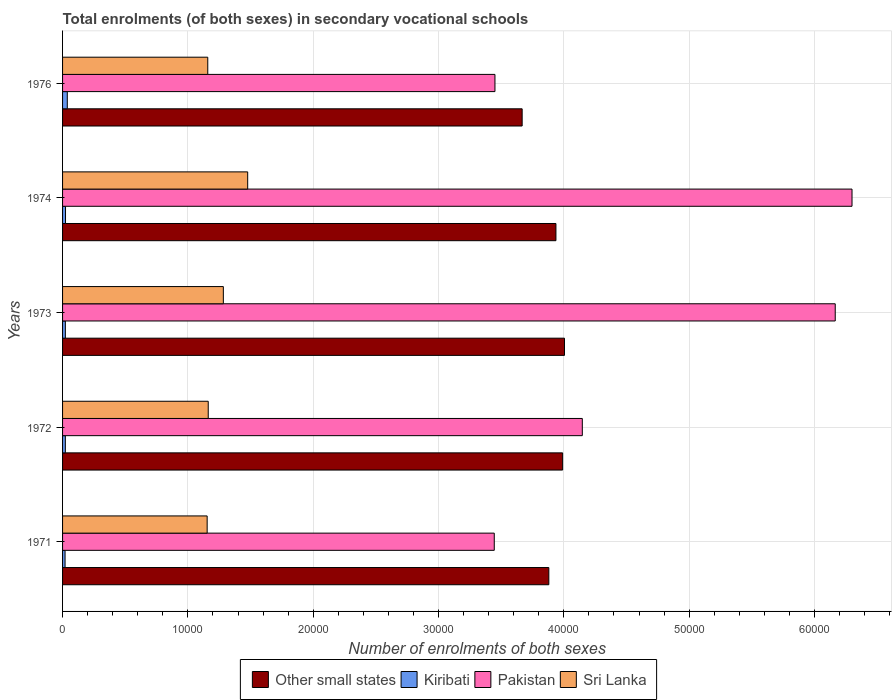How many different coloured bars are there?
Your answer should be very brief. 4. In how many cases, is the number of bars for a given year not equal to the number of legend labels?
Provide a succinct answer. 0. What is the number of enrolments in secondary schools in Pakistan in 1974?
Provide a short and direct response. 6.30e+04. Across all years, what is the maximum number of enrolments in secondary schools in Sri Lanka?
Provide a short and direct response. 1.48e+04. Across all years, what is the minimum number of enrolments in secondary schools in Kiribati?
Ensure brevity in your answer.  199. In which year was the number of enrolments in secondary schools in Pakistan maximum?
Your response must be concise. 1974. In which year was the number of enrolments in secondary schools in Sri Lanka minimum?
Offer a terse response. 1971. What is the total number of enrolments in secondary schools in Sri Lanka in the graph?
Provide a succinct answer. 6.24e+04. What is the difference between the number of enrolments in secondary schools in Pakistan in 1974 and that in 1976?
Provide a short and direct response. 2.85e+04. What is the difference between the number of enrolments in secondary schools in Other small states in 1973 and the number of enrolments in secondary schools in Sri Lanka in 1976?
Your answer should be compact. 2.85e+04. What is the average number of enrolments in secondary schools in Kiribati per year?
Make the answer very short. 251.4. In the year 1974, what is the difference between the number of enrolments in secondary schools in Other small states and number of enrolments in secondary schools in Sri Lanka?
Offer a terse response. 2.46e+04. What is the ratio of the number of enrolments in secondary schools in Kiribati in 1972 to that in 1976?
Offer a terse response. 0.59. Is the number of enrolments in secondary schools in Kiribati in 1971 less than that in 1973?
Make the answer very short. Yes. What is the difference between the highest and the second highest number of enrolments in secondary schools in Sri Lanka?
Provide a short and direct response. 1943. What is the difference between the highest and the lowest number of enrolments in secondary schools in Other small states?
Offer a terse response. 3377.85. In how many years, is the number of enrolments in secondary schools in Other small states greater than the average number of enrolments in secondary schools in Other small states taken over all years?
Your answer should be compact. 3. Is the sum of the number of enrolments in secondary schools in Kiribati in 1972 and 1974 greater than the maximum number of enrolments in secondary schools in Sri Lanka across all years?
Your answer should be compact. No. Is it the case that in every year, the sum of the number of enrolments in secondary schools in Pakistan and number of enrolments in secondary schools in Kiribati is greater than the sum of number of enrolments in secondary schools in Sri Lanka and number of enrolments in secondary schools in Other small states?
Your answer should be compact. Yes. What does the 1st bar from the top in 1971 represents?
Provide a short and direct response. Sri Lanka. What does the 3rd bar from the bottom in 1972 represents?
Give a very brief answer. Pakistan. Is it the case that in every year, the sum of the number of enrolments in secondary schools in Other small states and number of enrolments in secondary schools in Kiribati is greater than the number of enrolments in secondary schools in Sri Lanka?
Keep it short and to the point. Yes. Does the graph contain any zero values?
Offer a terse response. No. Does the graph contain grids?
Offer a very short reply. Yes. What is the title of the graph?
Ensure brevity in your answer.  Total enrolments (of both sexes) in secondary vocational schools. What is the label or title of the X-axis?
Provide a succinct answer. Number of enrolments of both sexes. What is the label or title of the Y-axis?
Provide a succinct answer. Years. What is the Number of enrolments of both sexes in Other small states in 1971?
Provide a succinct answer. 3.88e+04. What is the Number of enrolments of both sexes in Kiribati in 1971?
Provide a short and direct response. 199. What is the Number of enrolments of both sexes in Pakistan in 1971?
Ensure brevity in your answer.  3.44e+04. What is the Number of enrolments of both sexes of Sri Lanka in 1971?
Ensure brevity in your answer.  1.15e+04. What is the Number of enrolments of both sexes of Other small states in 1972?
Your response must be concise. 3.99e+04. What is the Number of enrolments of both sexes in Kiribati in 1972?
Make the answer very short. 222. What is the Number of enrolments of both sexes of Pakistan in 1972?
Give a very brief answer. 4.15e+04. What is the Number of enrolments of both sexes in Sri Lanka in 1972?
Your answer should be very brief. 1.16e+04. What is the Number of enrolments of both sexes in Other small states in 1973?
Make the answer very short. 4.01e+04. What is the Number of enrolments of both sexes in Kiribati in 1973?
Your response must be concise. 223. What is the Number of enrolments of both sexes in Pakistan in 1973?
Give a very brief answer. 6.17e+04. What is the Number of enrolments of both sexes of Sri Lanka in 1973?
Make the answer very short. 1.28e+04. What is the Number of enrolments of both sexes of Other small states in 1974?
Provide a succinct answer. 3.94e+04. What is the Number of enrolments of both sexes in Kiribati in 1974?
Provide a succinct answer. 235. What is the Number of enrolments of both sexes of Pakistan in 1974?
Your answer should be compact. 6.30e+04. What is the Number of enrolments of both sexes in Sri Lanka in 1974?
Provide a short and direct response. 1.48e+04. What is the Number of enrolments of both sexes of Other small states in 1976?
Your response must be concise. 3.67e+04. What is the Number of enrolments of both sexes in Kiribati in 1976?
Your answer should be very brief. 378. What is the Number of enrolments of both sexes in Pakistan in 1976?
Make the answer very short. 3.45e+04. What is the Number of enrolments of both sexes in Sri Lanka in 1976?
Provide a short and direct response. 1.16e+04. Across all years, what is the maximum Number of enrolments of both sexes of Other small states?
Give a very brief answer. 4.01e+04. Across all years, what is the maximum Number of enrolments of both sexes in Kiribati?
Give a very brief answer. 378. Across all years, what is the maximum Number of enrolments of both sexes of Pakistan?
Your response must be concise. 6.30e+04. Across all years, what is the maximum Number of enrolments of both sexes in Sri Lanka?
Give a very brief answer. 1.48e+04. Across all years, what is the minimum Number of enrolments of both sexes in Other small states?
Give a very brief answer. 3.67e+04. Across all years, what is the minimum Number of enrolments of both sexes in Kiribati?
Make the answer very short. 199. Across all years, what is the minimum Number of enrolments of both sexes in Pakistan?
Give a very brief answer. 3.44e+04. Across all years, what is the minimum Number of enrolments of both sexes of Sri Lanka?
Make the answer very short. 1.15e+04. What is the total Number of enrolments of both sexes in Other small states in the graph?
Your answer should be compact. 1.95e+05. What is the total Number of enrolments of both sexes of Kiribati in the graph?
Offer a very short reply. 1257. What is the total Number of enrolments of both sexes of Pakistan in the graph?
Your answer should be very brief. 2.35e+05. What is the total Number of enrolments of both sexes in Sri Lanka in the graph?
Your answer should be compact. 6.24e+04. What is the difference between the Number of enrolments of both sexes in Other small states in 1971 and that in 1972?
Offer a terse response. -1102.91. What is the difference between the Number of enrolments of both sexes in Kiribati in 1971 and that in 1972?
Your answer should be compact. -23. What is the difference between the Number of enrolments of both sexes in Pakistan in 1971 and that in 1972?
Make the answer very short. -7026. What is the difference between the Number of enrolments of both sexes in Sri Lanka in 1971 and that in 1972?
Ensure brevity in your answer.  -87. What is the difference between the Number of enrolments of both sexes of Other small states in 1971 and that in 1973?
Keep it short and to the point. -1249.68. What is the difference between the Number of enrolments of both sexes in Pakistan in 1971 and that in 1973?
Provide a short and direct response. -2.72e+04. What is the difference between the Number of enrolments of both sexes in Sri Lanka in 1971 and that in 1973?
Keep it short and to the point. -1292. What is the difference between the Number of enrolments of both sexes of Other small states in 1971 and that in 1974?
Provide a short and direct response. -567.78. What is the difference between the Number of enrolments of both sexes of Kiribati in 1971 and that in 1974?
Make the answer very short. -36. What is the difference between the Number of enrolments of both sexes in Pakistan in 1971 and that in 1974?
Offer a very short reply. -2.85e+04. What is the difference between the Number of enrolments of both sexes in Sri Lanka in 1971 and that in 1974?
Your answer should be very brief. -3235. What is the difference between the Number of enrolments of both sexes in Other small states in 1971 and that in 1976?
Your response must be concise. 2128.18. What is the difference between the Number of enrolments of both sexes of Kiribati in 1971 and that in 1976?
Provide a succinct answer. -179. What is the difference between the Number of enrolments of both sexes in Pakistan in 1971 and that in 1976?
Provide a short and direct response. -55. What is the difference between the Number of enrolments of both sexes in Sri Lanka in 1971 and that in 1976?
Give a very brief answer. -49. What is the difference between the Number of enrolments of both sexes of Other small states in 1972 and that in 1973?
Your response must be concise. -146.76. What is the difference between the Number of enrolments of both sexes of Pakistan in 1972 and that in 1973?
Provide a short and direct response. -2.02e+04. What is the difference between the Number of enrolments of both sexes of Sri Lanka in 1972 and that in 1973?
Ensure brevity in your answer.  -1205. What is the difference between the Number of enrolments of both sexes in Other small states in 1972 and that in 1974?
Give a very brief answer. 535.14. What is the difference between the Number of enrolments of both sexes of Pakistan in 1972 and that in 1974?
Ensure brevity in your answer.  -2.15e+04. What is the difference between the Number of enrolments of both sexes in Sri Lanka in 1972 and that in 1974?
Your answer should be very brief. -3148. What is the difference between the Number of enrolments of both sexes of Other small states in 1972 and that in 1976?
Your answer should be very brief. 3231.09. What is the difference between the Number of enrolments of both sexes of Kiribati in 1972 and that in 1976?
Offer a very short reply. -156. What is the difference between the Number of enrolments of both sexes in Pakistan in 1972 and that in 1976?
Offer a very short reply. 6971. What is the difference between the Number of enrolments of both sexes of Other small states in 1973 and that in 1974?
Ensure brevity in your answer.  681.9. What is the difference between the Number of enrolments of both sexes in Kiribati in 1973 and that in 1974?
Keep it short and to the point. -12. What is the difference between the Number of enrolments of both sexes of Pakistan in 1973 and that in 1974?
Make the answer very short. -1340. What is the difference between the Number of enrolments of both sexes in Sri Lanka in 1973 and that in 1974?
Provide a short and direct response. -1943. What is the difference between the Number of enrolments of both sexes in Other small states in 1973 and that in 1976?
Offer a terse response. 3377.85. What is the difference between the Number of enrolments of both sexes of Kiribati in 1973 and that in 1976?
Offer a very short reply. -155. What is the difference between the Number of enrolments of both sexes of Pakistan in 1973 and that in 1976?
Provide a succinct answer. 2.72e+04. What is the difference between the Number of enrolments of both sexes of Sri Lanka in 1973 and that in 1976?
Give a very brief answer. 1243. What is the difference between the Number of enrolments of both sexes of Other small states in 1974 and that in 1976?
Your response must be concise. 2695.95. What is the difference between the Number of enrolments of both sexes in Kiribati in 1974 and that in 1976?
Your answer should be very brief. -143. What is the difference between the Number of enrolments of both sexes in Pakistan in 1974 and that in 1976?
Your answer should be very brief. 2.85e+04. What is the difference between the Number of enrolments of both sexes of Sri Lanka in 1974 and that in 1976?
Make the answer very short. 3186. What is the difference between the Number of enrolments of both sexes of Other small states in 1971 and the Number of enrolments of both sexes of Kiribati in 1972?
Provide a succinct answer. 3.86e+04. What is the difference between the Number of enrolments of both sexes in Other small states in 1971 and the Number of enrolments of both sexes in Pakistan in 1972?
Your response must be concise. -2672.13. What is the difference between the Number of enrolments of both sexes in Other small states in 1971 and the Number of enrolments of both sexes in Sri Lanka in 1972?
Make the answer very short. 2.72e+04. What is the difference between the Number of enrolments of both sexes of Kiribati in 1971 and the Number of enrolments of both sexes of Pakistan in 1972?
Your answer should be very brief. -4.13e+04. What is the difference between the Number of enrolments of both sexes of Kiribati in 1971 and the Number of enrolments of both sexes of Sri Lanka in 1972?
Your response must be concise. -1.14e+04. What is the difference between the Number of enrolments of both sexes of Pakistan in 1971 and the Number of enrolments of both sexes of Sri Lanka in 1972?
Keep it short and to the point. 2.28e+04. What is the difference between the Number of enrolments of both sexes in Other small states in 1971 and the Number of enrolments of both sexes in Kiribati in 1973?
Offer a very short reply. 3.86e+04. What is the difference between the Number of enrolments of both sexes of Other small states in 1971 and the Number of enrolments of both sexes of Pakistan in 1973?
Keep it short and to the point. -2.29e+04. What is the difference between the Number of enrolments of both sexes in Other small states in 1971 and the Number of enrolments of both sexes in Sri Lanka in 1973?
Give a very brief answer. 2.60e+04. What is the difference between the Number of enrolments of both sexes of Kiribati in 1971 and the Number of enrolments of both sexes of Pakistan in 1973?
Make the answer very short. -6.15e+04. What is the difference between the Number of enrolments of both sexes of Kiribati in 1971 and the Number of enrolments of both sexes of Sri Lanka in 1973?
Keep it short and to the point. -1.26e+04. What is the difference between the Number of enrolments of both sexes in Pakistan in 1971 and the Number of enrolments of both sexes in Sri Lanka in 1973?
Keep it short and to the point. 2.16e+04. What is the difference between the Number of enrolments of both sexes in Other small states in 1971 and the Number of enrolments of both sexes in Kiribati in 1974?
Give a very brief answer. 3.86e+04. What is the difference between the Number of enrolments of both sexes of Other small states in 1971 and the Number of enrolments of both sexes of Pakistan in 1974?
Ensure brevity in your answer.  -2.42e+04. What is the difference between the Number of enrolments of both sexes of Other small states in 1971 and the Number of enrolments of both sexes of Sri Lanka in 1974?
Provide a short and direct response. 2.40e+04. What is the difference between the Number of enrolments of both sexes of Kiribati in 1971 and the Number of enrolments of both sexes of Pakistan in 1974?
Keep it short and to the point. -6.28e+04. What is the difference between the Number of enrolments of both sexes in Kiribati in 1971 and the Number of enrolments of both sexes in Sri Lanka in 1974?
Offer a very short reply. -1.46e+04. What is the difference between the Number of enrolments of both sexes of Pakistan in 1971 and the Number of enrolments of both sexes of Sri Lanka in 1974?
Your response must be concise. 1.97e+04. What is the difference between the Number of enrolments of both sexes of Other small states in 1971 and the Number of enrolments of both sexes of Kiribati in 1976?
Offer a very short reply. 3.84e+04. What is the difference between the Number of enrolments of both sexes in Other small states in 1971 and the Number of enrolments of both sexes in Pakistan in 1976?
Keep it short and to the point. 4298.87. What is the difference between the Number of enrolments of both sexes in Other small states in 1971 and the Number of enrolments of both sexes in Sri Lanka in 1976?
Provide a succinct answer. 2.72e+04. What is the difference between the Number of enrolments of both sexes of Kiribati in 1971 and the Number of enrolments of both sexes of Pakistan in 1976?
Your answer should be compact. -3.43e+04. What is the difference between the Number of enrolments of both sexes of Kiribati in 1971 and the Number of enrolments of both sexes of Sri Lanka in 1976?
Give a very brief answer. -1.14e+04. What is the difference between the Number of enrolments of both sexes in Pakistan in 1971 and the Number of enrolments of both sexes in Sri Lanka in 1976?
Make the answer very short. 2.29e+04. What is the difference between the Number of enrolments of both sexes of Other small states in 1972 and the Number of enrolments of both sexes of Kiribati in 1973?
Make the answer very short. 3.97e+04. What is the difference between the Number of enrolments of both sexes of Other small states in 1972 and the Number of enrolments of both sexes of Pakistan in 1973?
Offer a terse response. -2.18e+04. What is the difference between the Number of enrolments of both sexes of Other small states in 1972 and the Number of enrolments of both sexes of Sri Lanka in 1973?
Make the answer very short. 2.71e+04. What is the difference between the Number of enrolments of both sexes in Kiribati in 1972 and the Number of enrolments of both sexes in Pakistan in 1973?
Keep it short and to the point. -6.14e+04. What is the difference between the Number of enrolments of both sexes of Kiribati in 1972 and the Number of enrolments of both sexes of Sri Lanka in 1973?
Make the answer very short. -1.26e+04. What is the difference between the Number of enrolments of both sexes of Pakistan in 1972 and the Number of enrolments of both sexes of Sri Lanka in 1973?
Offer a terse response. 2.86e+04. What is the difference between the Number of enrolments of both sexes of Other small states in 1972 and the Number of enrolments of both sexes of Kiribati in 1974?
Give a very brief answer. 3.97e+04. What is the difference between the Number of enrolments of both sexes in Other small states in 1972 and the Number of enrolments of both sexes in Pakistan in 1974?
Give a very brief answer. -2.31e+04. What is the difference between the Number of enrolments of both sexes in Other small states in 1972 and the Number of enrolments of both sexes in Sri Lanka in 1974?
Offer a very short reply. 2.51e+04. What is the difference between the Number of enrolments of both sexes in Kiribati in 1972 and the Number of enrolments of both sexes in Pakistan in 1974?
Your answer should be compact. -6.28e+04. What is the difference between the Number of enrolments of both sexes of Kiribati in 1972 and the Number of enrolments of both sexes of Sri Lanka in 1974?
Provide a succinct answer. -1.46e+04. What is the difference between the Number of enrolments of both sexes in Pakistan in 1972 and the Number of enrolments of both sexes in Sri Lanka in 1974?
Ensure brevity in your answer.  2.67e+04. What is the difference between the Number of enrolments of both sexes of Other small states in 1972 and the Number of enrolments of both sexes of Kiribati in 1976?
Your answer should be very brief. 3.95e+04. What is the difference between the Number of enrolments of both sexes of Other small states in 1972 and the Number of enrolments of both sexes of Pakistan in 1976?
Provide a succinct answer. 5401.79. What is the difference between the Number of enrolments of both sexes in Other small states in 1972 and the Number of enrolments of both sexes in Sri Lanka in 1976?
Offer a terse response. 2.83e+04. What is the difference between the Number of enrolments of both sexes in Kiribati in 1972 and the Number of enrolments of both sexes in Pakistan in 1976?
Provide a succinct answer. -3.43e+04. What is the difference between the Number of enrolments of both sexes in Kiribati in 1972 and the Number of enrolments of both sexes in Sri Lanka in 1976?
Your answer should be compact. -1.14e+04. What is the difference between the Number of enrolments of both sexes in Pakistan in 1972 and the Number of enrolments of both sexes in Sri Lanka in 1976?
Your answer should be very brief. 2.99e+04. What is the difference between the Number of enrolments of both sexes of Other small states in 1973 and the Number of enrolments of both sexes of Kiribati in 1974?
Your answer should be compact. 3.98e+04. What is the difference between the Number of enrolments of both sexes of Other small states in 1973 and the Number of enrolments of both sexes of Pakistan in 1974?
Offer a terse response. -2.29e+04. What is the difference between the Number of enrolments of both sexes of Other small states in 1973 and the Number of enrolments of both sexes of Sri Lanka in 1974?
Your answer should be very brief. 2.53e+04. What is the difference between the Number of enrolments of both sexes of Kiribati in 1973 and the Number of enrolments of both sexes of Pakistan in 1974?
Your response must be concise. -6.28e+04. What is the difference between the Number of enrolments of both sexes in Kiribati in 1973 and the Number of enrolments of both sexes in Sri Lanka in 1974?
Ensure brevity in your answer.  -1.46e+04. What is the difference between the Number of enrolments of both sexes of Pakistan in 1973 and the Number of enrolments of both sexes of Sri Lanka in 1974?
Offer a terse response. 4.69e+04. What is the difference between the Number of enrolments of both sexes in Other small states in 1973 and the Number of enrolments of both sexes in Kiribati in 1976?
Keep it short and to the point. 3.97e+04. What is the difference between the Number of enrolments of both sexes in Other small states in 1973 and the Number of enrolments of both sexes in Pakistan in 1976?
Provide a succinct answer. 5548.55. What is the difference between the Number of enrolments of both sexes in Other small states in 1973 and the Number of enrolments of both sexes in Sri Lanka in 1976?
Provide a short and direct response. 2.85e+04. What is the difference between the Number of enrolments of both sexes in Kiribati in 1973 and the Number of enrolments of both sexes in Pakistan in 1976?
Keep it short and to the point. -3.43e+04. What is the difference between the Number of enrolments of both sexes in Kiribati in 1973 and the Number of enrolments of both sexes in Sri Lanka in 1976?
Offer a very short reply. -1.14e+04. What is the difference between the Number of enrolments of both sexes of Pakistan in 1973 and the Number of enrolments of both sexes of Sri Lanka in 1976?
Your answer should be compact. 5.01e+04. What is the difference between the Number of enrolments of both sexes of Other small states in 1974 and the Number of enrolments of both sexes of Kiribati in 1976?
Offer a terse response. 3.90e+04. What is the difference between the Number of enrolments of both sexes in Other small states in 1974 and the Number of enrolments of both sexes in Pakistan in 1976?
Make the answer very short. 4866.65. What is the difference between the Number of enrolments of both sexes in Other small states in 1974 and the Number of enrolments of both sexes in Sri Lanka in 1976?
Make the answer very short. 2.78e+04. What is the difference between the Number of enrolments of both sexes of Kiribati in 1974 and the Number of enrolments of both sexes of Pakistan in 1976?
Provide a succinct answer. -3.43e+04. What is the difference between the Number of enrolments of both sexes of Kiribati in 1974 and the Number of enrolments of both sexes of Sri Lanka in 1976?
Make the answer very short. -1.14e+04. What is the difference between the Number of enrolments of both sexes of Pakistan in 1974 and the Number of enrolments of both sexes of Sri Lanka in 1976?
Offer a terse response. 5.14e+04. What is the average Number of enrolments of both sexes of Other small states per year?
Provide a succinct answer. 3.90e+04. What is the average Number of enrolments of both sexes in Kiribati per year?
Your answer should be compact. 251.4. What is the average Number of enrolments of both sexes of Pakistan per year?
Offer a terse response. 4.70e+04. What is the average Number of enrolments of both sexes in Sri Lanka per year?
Keep it short and to the point. 1.25e+04. In the year 1971, what is the difference between the Number of enrolments of both sexes in Other small states and Number of enrolments of both sexes in Kiribati?
Offer a terse response. 3.86e+04. In the year 1971, what is the difference between the Number of enrolments of both sexes of Other small states and Number of enrolments of both sexes of Pakistan?
Give a very brief answer. 4353.87. In the year 1971, what is the difference between the Number of enrolments of both sexes of Other small states and Number of enrolments of both sexes of Sri Lanka?
Offer a terse response. 2.73e+04. In the year 1971, what is the difference between the Number of enrolments of both sexes in Kiribati and Number of enrolments of both sexes in Pakistan?
Provide a succinct answer. -3.43e+04. In the year 1971, what is the difference between the Number of enrolments of both sexes in Kiribati and Number of enrolments of both sexes in Sri Lanka?
Make the answer very short. -1.13e+04. In the year 1971, what is the difference between the Number of enrolments of both sexes of Pakistan and Number of enrolments of both sexes of Sri Lanka?
Offer a terse response. 2.29e+04. In the year 1972, what is the difference between the Number of enrolments of both sexes of Other small states and Number of enrolments of both sexes of Kiribati?
Ensure brevity in your answer.  3.97e+04. In the year 1972, what is the difference between the Number of enrolments of both sexes of Other small states and Number of enrolments of both sexes of Pakistan?
Offer a very short reply. -1569.21. In the year 1972, what is the difference between the Number of enrolments of both sexes of Other small states and Number of enrolments of both sexes of Sri Lanka?
Your answer should be compact. 2.83e+04. In the year 1972, what is the difference between the Number of enrolments of both sexes of Kiribati and Number of enrolments of both sexes of Pakistan?
Make the answer very short. -4.13e+04. In the year 1972, what is the difference between the Number of enrolments of both sexes in Kiribati and Number of enrolments of both sexes in Sri Lanka?
Provide a succinct answer. -1.14e+04. In the year 1972, what is the difference between the Number of enrolments of both sexes in Pakistan and Number of enrolments of both sexes in Sri Lanka?
Give a very brief answer. 2.99e+04. In the year 1973, what is the difference between the Number of enrolments of both sexes in Other small states and Number of enrolments of both sexes in Kiribati?
Offer a terse response. 3.98e+04. In the year 1973, what is the difference between the Number of enrolments of both sexes of Other small states and Number of enrolments of both sexes of Pakistan?
Offer a terse response. -2.16e+04. In the year 1973, what is the difference between the Number of enrolments of both sexes in Other small states and Number of enrolments of both sexes in Sri Lanka?
Your response must be concise. 2.72e+04. In the year 1973, what is the difference between the Number of enrolments of both sexes in Kiribati and Number of enrolments of both sexes in Pakistan?
Give a very brief answer. -6.14e+04. In the year 1973, what is the difference between the Number of enrolments of both sexes in Kiribati and Number of enrolments of both sexes in Sri Lanka?
Offer a very short reply. -1.26e+04. In the year 1973, what is the difference between the Number of enrolments of both sexes in Pakistan and Number of enrolments of both sexes in Sri Lanka?
Ensure brevity in your answer.  4.88e+04. In the year 1974, what is the difference between the Number of enrolments of both sexes in Other small states and Number of enrolments of both sexes in Kiribati?
Ensure brevity in your answer.  3.91e+04. In the year 1974, what is the difference between the Number of enrolments of both sexes of Other small states and Number of enrolments of both sexes of Pakistan?
Your answer should be very brief. -2.36e+04. In the year 1974, what is the difference between the Number of enrolments of both sexes in Other small states and Number of enrolments of both sexes in Sri Lanka?
Keep it short and to the point. 2.46e+04. In the year 1974, what is the difference between the Number of enrolments of both sexes in Kiribati and Number of enrolments of both sexes in Pakistan?
Offer a terse response. -6.28e+04. In the year 1974, what is the difference between the Number of enrolments of both sexes in Kiribati and Number of enrolments of both sexes in Sri Lanka?
Offer a very short reply. -1.45e+04. In the year 1974, what is the difference between the Number of enrolments of both sexes in Pakistan and Number of enrolments of both sexes in Sri Lanka?
Ensure brevity in your answer.  4.82e+04. In the year 1976, what is the difference between the Number of enrolments of both sexes of Other small states and Number of enrolments of both sexes of Kiribati?
Offer a very short reply. 3.63e+04. In the year 1976, what is the difference between the Number of enrolments of both sexes of Other small states and Number of enrolments of both sexes of Pakistan?
Your answer should be compact. 2170.7. In the year 1976, what is the difference between the Number of enrolments of both sexes in Other small states and Number of enrolments of both sexes in Sri Lanka?
Your answer should be very brief. 2.51e+04. In the year 1976, what is the difference between the Number of enrolments of both sexes in Kiribati and Number of enrolments of both sexes in Pakistan?
Offer a terse response. -3.41e+04. In the year 1976, what is the difference between the Number of enrolments of both sexes in Kiribati and Number of enrolments of both sexes in Sri Lanka?
Provide a short and direct response. -1.12e+04. In the year 1976, what is the difference between the Number of enrolments of both sexes in Pakistan and Number of enrolments of both sexes in Sri Lanka?
Your answer should be compact. 2.29e+04. What is the ratio of the Number of enrolments of both sexes of Other small states in 1971 to that in 1972?
Provide a short and direct response. 0.97. What is the ratio of the Number of enrolments of both sexes in Kiribati in 1971 to that in 1972?
Offer a very short reply. 0.9. What is the ratio of the Number of enrolments of both sexes of Pakistan in 1971 to that in 1972?
Provide a succinct answer. 0.83. What is the ratio of the Number of enrolments of both sexes of Sri Lanka in 1971 to that in 1972?
Your answer should be compact. 0.99. What is the ratio of the Number of enrolments of both sexes in Other small states in 1971 to that in 1973?
Your answer should be compact. 0.97. What is the ratio of the Number of enrolments of both sexes in Kiribati in 1971 to that in 1973?
Provide a short and direct response. 0.89. What is the ratio of the Number of enrolments of both sexes of Pakistan in 1971 to that in 1973?
Your response must be concise. 0.56. What is the ratio of the Number of enrolments of both sexes of Sri Lanka in 1971 to that in 1973?
Your answer should be very brief. 0.9. What is the ratio of the Number of enrolments of both sexes of Other small states in 1971 to that in 1974?
Your answer should be very brief. 0.99. What is the ratio of the Number of enrolments of both sexes of Kiribati in 1971 to that in 1974?
Provide a succinct answer. 0.85. What is the ratio of the Number of enrolments of both sexes in Pakistan in 1971 to that in 1974?
Make the answer very short. 0.55. What is the ratio of the Number of enrolments of both sexes of Sri Lanka in 1971 to that in 1974?
Ensure brevity in your answer.  0.78. What is the ratio of the Number of enrolments of both sexes of Other small states in 1971 to that in 1976?
Keep it short and to the point. 1.06. What is the ratio of the Number of enrolments of both sexes in Kiribati in 1971 to that in 1976?
Provide a succinct answer. 0.53. What is the ratio of the Number of enrolments of both sexes in Pakistan in 1971 to that in 1976?
Provide a succinct answer. 1. What is the ratio of the Number of enrolments of both sexes in Other small states in 1972 to that in 1973?
Make the answer very short. 1. What is the ratio of the Number of enrolments of both sexes in Kiribati in 1972 to that in 1973?
Ensure brevity in your answer.  1. What is the ratio of the Number of enrolments of both sexes of Pakistan in 1972 to that in 1973?
Give a very brief answer. 0.67. What is the ratio of the Number of enrolments of both sexes in Sri Lanka in 1972 to that in 1973?
Provide a short and direct response. 0.91. What is the ratio of the Number of enrolments of both sexes of Other small states in 1972 to that in 1974?
Your answer should be very brief. 1.01. What is the ratio of the Number of enrolments of both sexes in Kiribati in 1972 to that in 1974?
Make the answer very short. 0.94. What is the ratio of the Number of enrolments of both sexes of Pakistan in 1972 to that in 1974?
Give a very brief answer. 0.66. What is the ratio of the Number of enrolments of both sexes of Sri Lanka in 1972 to that in 1974?
Provide a succinct answer. 0.79. What is the ratio of the Number of enrolments of both sexes of Other small states in 1972 to that in 1976?
Your answer should be compact. 1.09. What is the ratio of the Number of enrolments of both sexes in Kiribati in 1972 to that in 1976?
Your answer should be very brief. 0.59. What is the ratio of the Number of enrolments of both sexes in Pakistan in 1972 to that in 1976?
Ensure brevity in your answer.  1.2. What is the ratio of the Number of enrolments of both sexes in Sri Lanka in 1972 to that in 1976?
Give a very brief answer. 1. What is the ratio of the Number of enrolments of both sexes in Other small states in 1973 to that in 1974?
Provide a succinct answer. 1.02. What is the ratio of the Number of enrolments of both sexes in Kiribati in 1973 to that in 1974?
Your answer should be very brief. 0.95. What is the ratio of the Number of enrolments of both sexes in Pakistan in 1973 to that in 1974?
Offer a terse response. 0.98. What is the ratio of the Number of enrolments of both sexes in Sri Lanka in 1973 to that in 1974?
Give a very brief answer. 0.87. What is the ratio of the Number of enrolments of both sexes of Other small states in 1973 to that in 1976?
Your answer should be very brief. 1.09. What is the ratio of the Number of enrolments of both sexes of Kiribati in 1973 to that in 1976?
Keep it short and to the point. 0.59. What is the ratio of the Number of enrolments of both sexes of Pakistan in 1973 to that in 1976?
Give a very brief answer. 1.79. What is the ratio of the Number of enrolments of both sexes in Sri Lanka in 1973 to that in 1976?
Provide a short and direct response. 1.11. What is the ratio of the Number of enrolments of both sexes in Other small states in 1974 to that in 1976?
Your answer should be compact. 1.07. What is the ratio of the Number of enrolments of both sexes in Kiribati in 1974 to that in 1976?
Provide a short and direct response. 0.62. What is the ratio of the Number of enrolments of both sexes of Pakistan in 1974 to that in 1976?
Offer a very short reply. 1.83. What is the ratio of the Number of enrolments of both sexes of Sri Lanka in 1974 to that in 1976?
Offer a terse response. 1.27. What is the difference between the highest and the second highest Number of enrolments of both sexes in Other small states?
Provide a short and direct response. 146.76. What is the difference between the highest and the second highest Number of enrolments of both sexes in Kiribati?
Ensure brevity in your answer.  143. What is the difference between the highest and the second highest Number of enrolments of both sexes of Pakistan?
Offer a very short reply. 1340. What is the difference between the highest and the second highest Number of enrolments of both sexes in Sri Lanka?
Offer a very short reply. 1943. What is the difference between the highest and the lowest Number of enrolments of both sexes of Other small states?
Ensure brevity in your answer.  3377.85. What is the difference between the highest and the lowest Number of enrolments of both sexes in Kiribati?
Your answer should be very brief. 179. What is the difference between the highest and the lowest Number of enrolments of both sexes in Pakistan?
Ensure brevity in your answer.  2.85e+04. What is the difference between the highest and the lowest Number of enrolments of both sexes in Sri Lanka?
Offer a very short reply. 3235. 